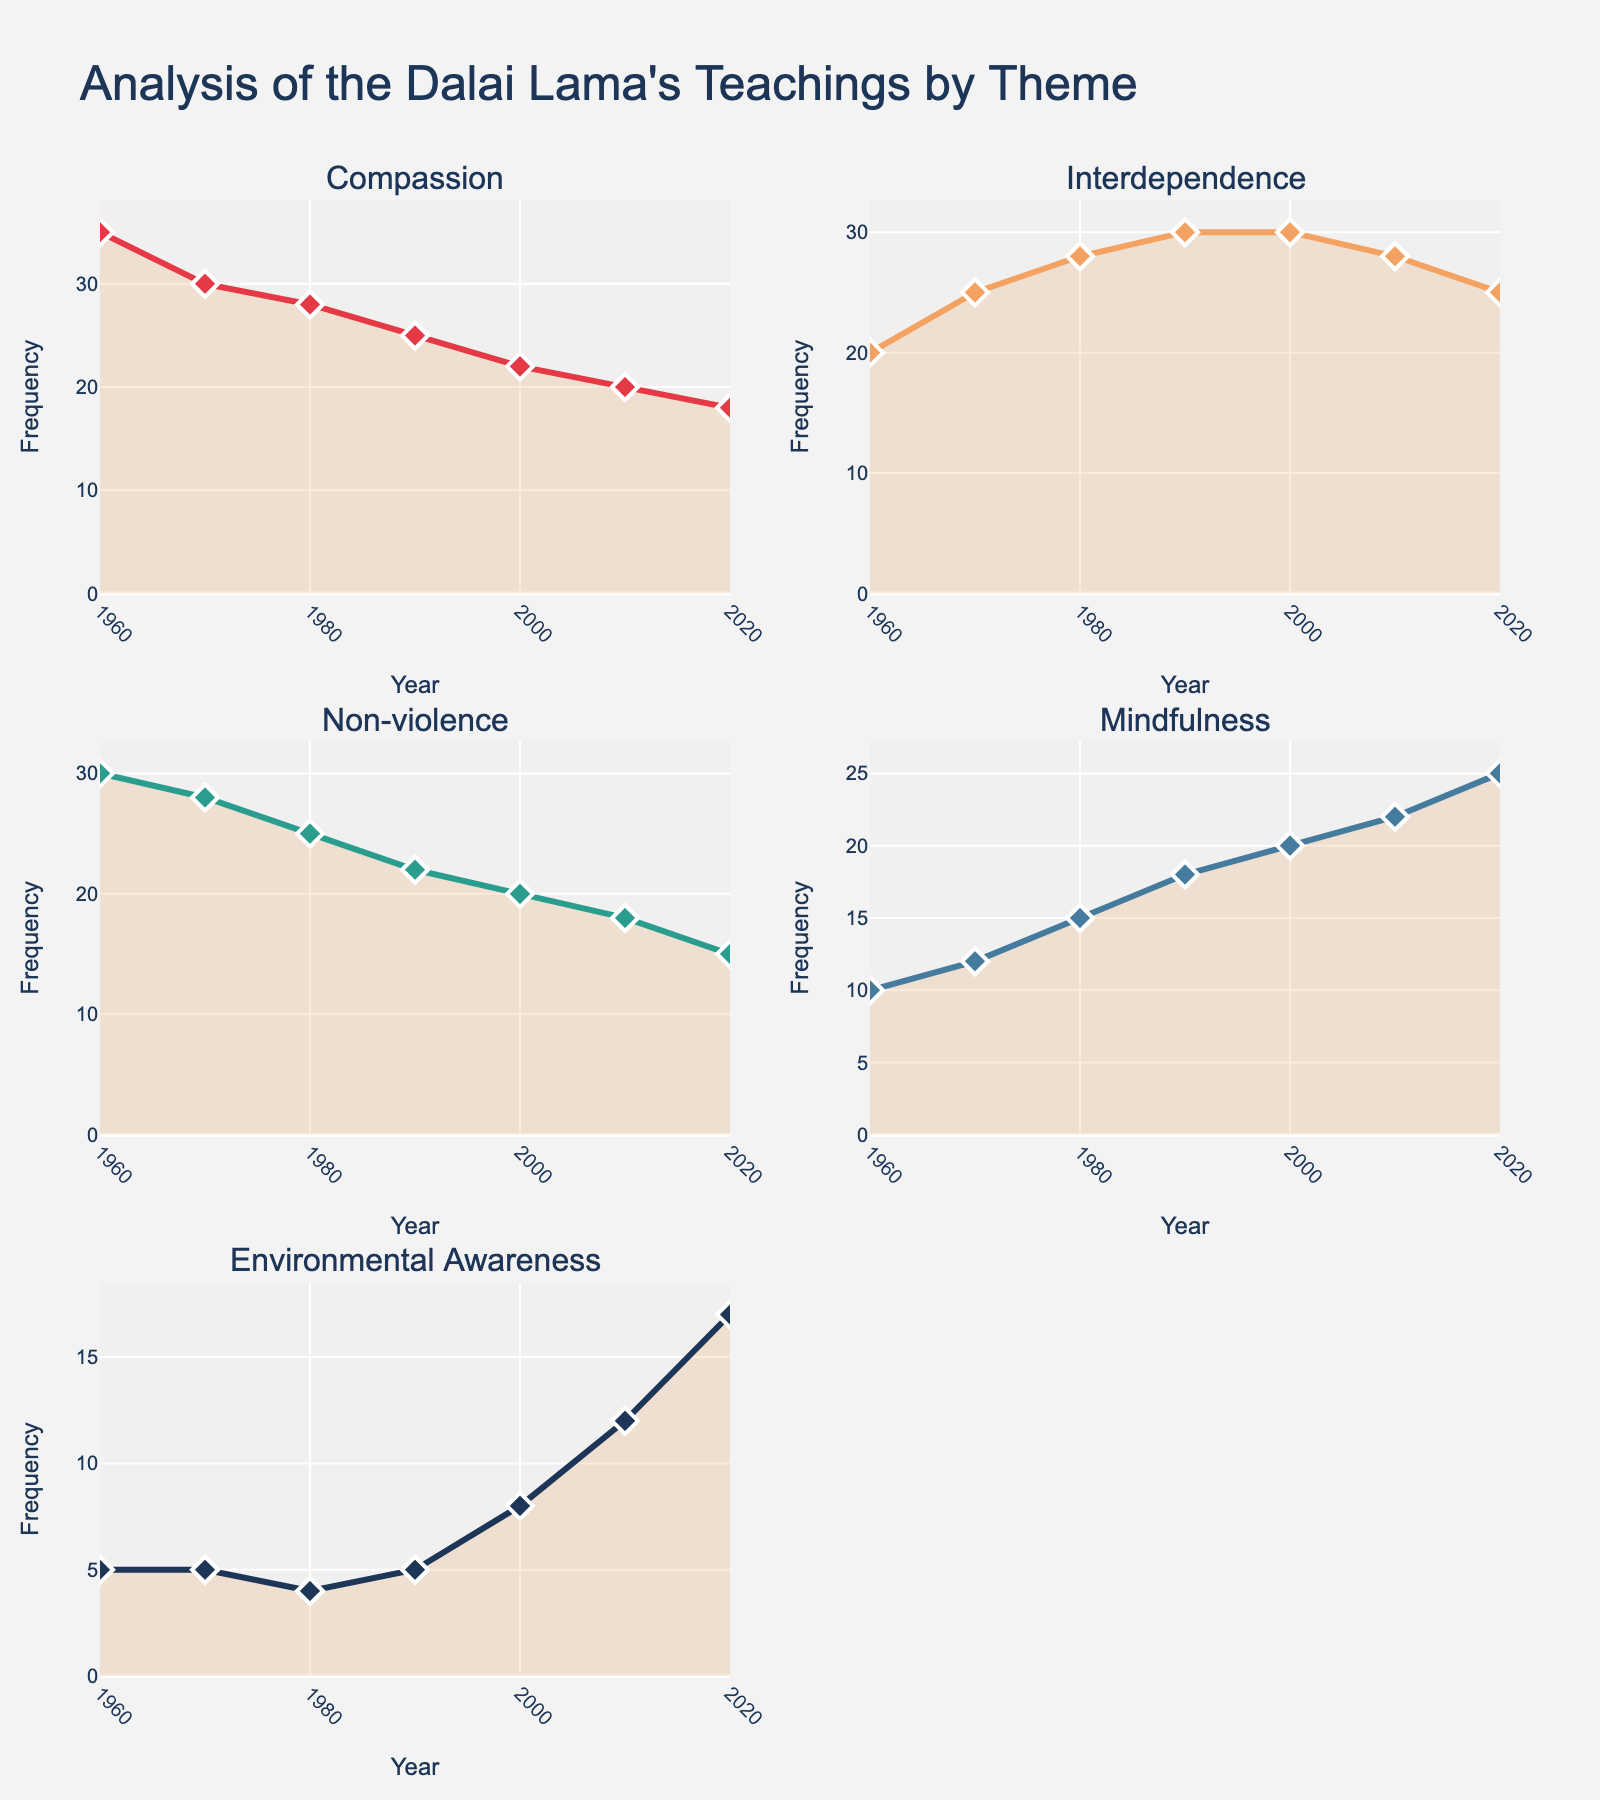What is the overall trend of the theme "Compassion" over the years? The figure shows that the frequency of "Compassion" in the Dalai Lama's teachings has decreased from 1960 to 2020. In 1960, the frequency was the highest at 35, and it gradually declined to 18 in 2020.
Answer: Declining How many themes are analyzed in the figure? By counting the subplot titles, you can see that there are five themes analyzed in the figure.
Answer: Five Between which consecutive decades did the theme "Environmental Awareness" see the largest increase? By comparing the differences between each decade, the largest increase for "Environmental Awareness" occurred from 2010 to 2020, where it rose from 12 to 17, an increase of 5 units.
Answer: 2010 to 2020 What was the frequency value of "Non-violence" in the year 2000? Check the subplot for "Non-violence", and the data point for the year 2000 shows a frequency of 20.
Answer: 20 Which theme has shown the highest frequency consistently over the years? By examining all subplots, "Compassion" has consistently shown the highest frequency compared to the other themes, especially in the earlier decades, peaking at 35 in 1960.
Answer: Compassion Compare the frequency of "Mindfulness" and "Interdependence" in the year 1990. Which was higher? In 1990, the data points for "Mindfulness" and "Interdependence" are 18 and 30, respectively, indicating that "Interdependence" had a higher frequency.
Answer: Interdependence What's the average frequency of the theme "Non-violence" over the six decades? Sum the frequencies of "Non-violence" from 1960 to 2020 (30+28+25+22+20+18+15) which equals 158, then divide by 7 (the number of data points), resulting in approximately 22.57.
Answer: 22.57 In which decade did "Mindfulness" surpass "Compassion" in frequency for the first time? "Mindfulness" surpassed "Compassion" for the first time in 2000. In 2000, "Mindfulness" had a frequency of 20, whereas "Compassion" had a frequency of 22.
Answer: 2000 